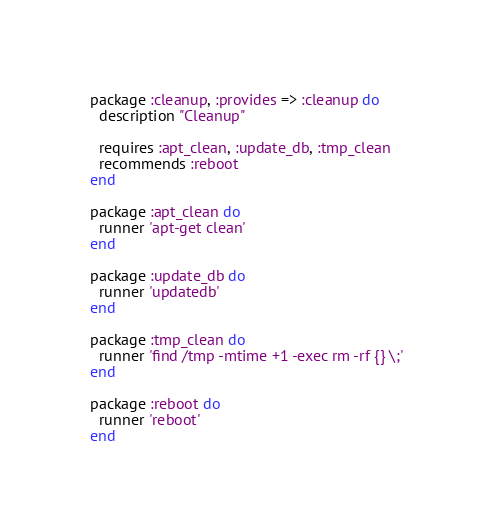Convert code to text. <code><loc_0><loc_0><loc_500><loc_500><_Ruby_>
package :cleanup, :provides => :cleanup do
  description "Cleanup"
  
  requires :apt_clean, :update_db, :tmp_clean
  recommends :reboot
end

package :apt_clean do
  runner 'apt-get clean'
end

package :update_db do
  runner 'updatedb'
end

package :tmp_clean do
  runner 'find /tmp -mtime +1 -exec rm -rf {} \;'
end

package :reboot do
  runner 'reboot'
end</code> 